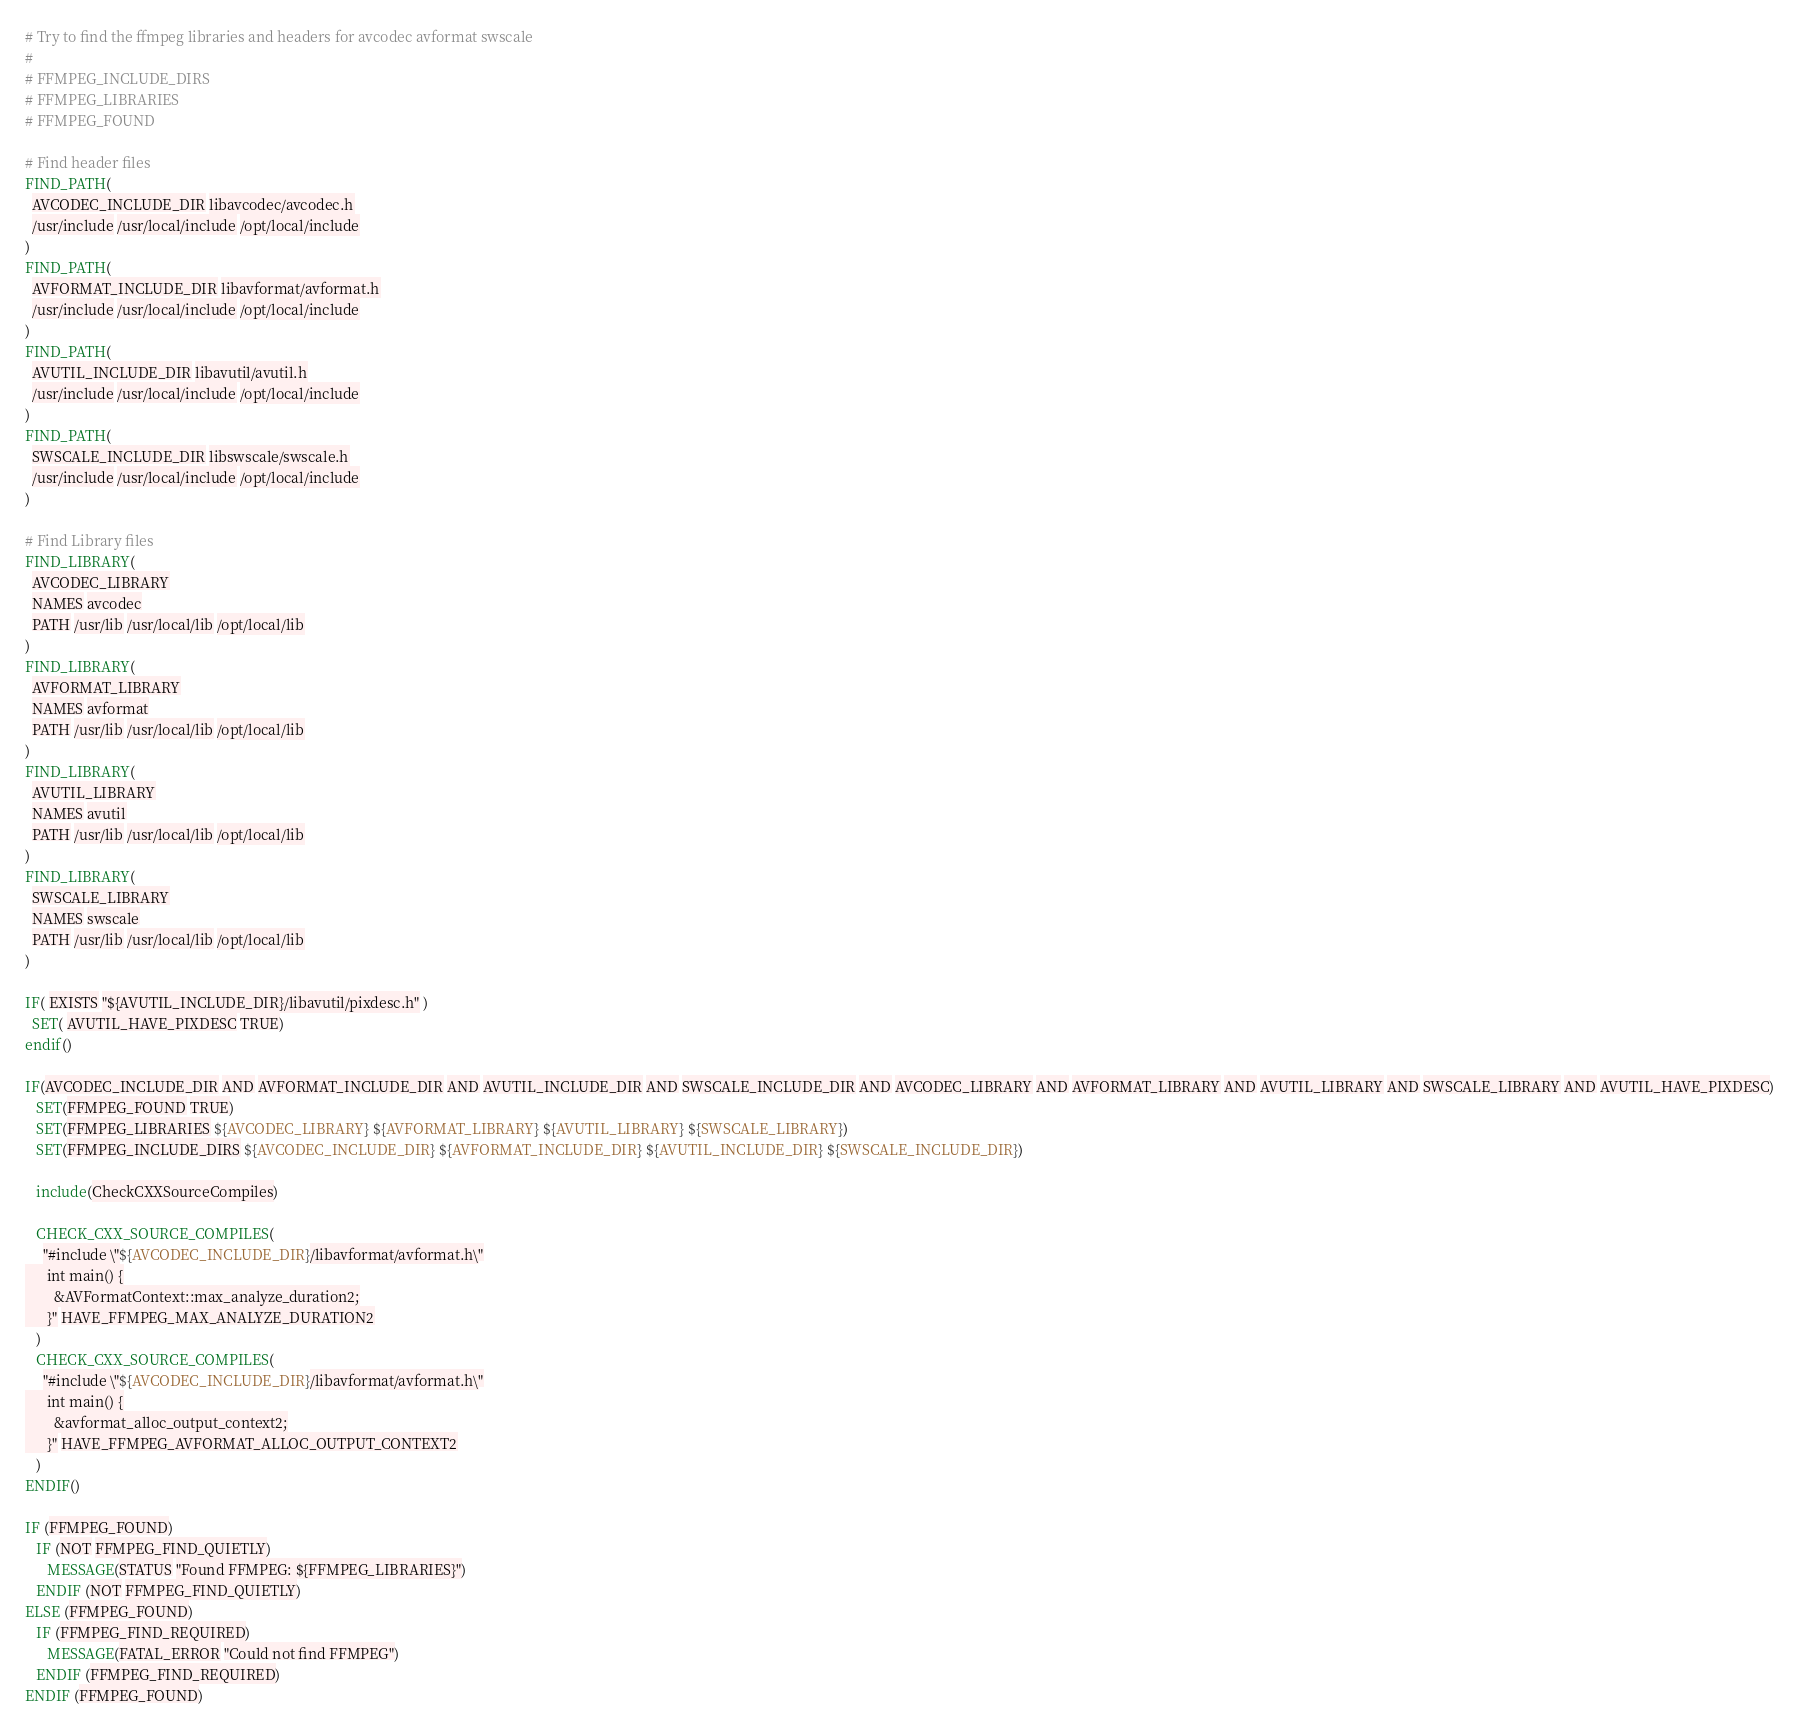<code> <loc_0><loc_0><loc_500><loc_500><_CMake_># Try to find the ffmpeg libraries and headers for avcodec avformat swscale
#
# FFMPEG_INCLUDE_DIRS
# FFMPEG_LIBRARIES
# FFMPEG_FOUND

# Find header files
FIND_PATH(
  AVCODEC_INCLUDE_DIR libavcodec/avcodec.h
  /usr/include /usr/local/include /opt/local/include
)
FIND_PATH(
  AVFORMAT_INCLUDE_DIR libavformat/avformat.h
  /usr/include /usr/local/include /opt/local/include
)
FIND_PATH(
  AVUTIL_INCLUDE_DIR libavutil/avutil.h
  /usr/include /usr/local/include /opt/local/include
)
FIND_PATH(
  SWSCALE_INCLUDE_DIR libswscale/swscale.h
  /usr/include /usr/local/include /opt/local/include
)

# Find Library files
FIND_LIBRARY(
  AVCODEC_LIBRARY
  NAMES avcodec
  PATH /usr/lib /usr/local/lib /opt/local/lib
)
FIND_LIBRARY(
  AVFORMAT_LIBRARY
  NAMES avformat
  PATH /usr/lib /usr/local/lib /opt/local/lib
)
FIND_LIBRARY(
  AVUTIL_LIBRARY
  NAMES avutil
  PATH /usr/lib /usr/local/lib /opt/local/lib
)
FIND_LIBRARY(
  SWSCALE_LIBRARY
  NAMES swscale
  PATH /usr/lib /usr/local/lib /opt/local/lib
)

IF( EXISTS "${AVUTIL_INCLUDE_DIR}/libavutil/pixdesc.h" )
  SET( AVUTIL_HAVE_PIXDESC TRUE)
endif()

IF(AVCODEC_INCLUDE_DIR AND AVFORMAT_INCLUDE_DIR AND AVUTIL_INCLUDE_DIR AND SWSCALE_INCLUDE_DIR AND AVCODEC_LIBRARY AND AVFORMAT_LIBRARY AND AVUTIL_LIBRARY AND SWSCALE_LIBRARY AND AVUTIL_HAVE_PIXDESC)
   SET(FFMPEG_FOUND TRUE)
   SET(FFMPEG_LIBRARIES ${AVCODEC_LIBRARY} ${AVFORMAT_LIBRARY} ${AVUTIL_LIBRARY} ${SWSCALE_LIBRARY})
   SET(FFMPEG_INCLUDE_DIRS ${AVCODEC_INCLUDE_DIR} ${AVFORMAT_INCLUDE_DIR} ${AVUTIL_INCLUDE_DIR} ${SWSCALE_INCLUDE_DIR})

   include(CheckCXXSourceCompiles)

   CHECK_CXX_SOURCE_COMPILES(
     "#include \"${AVCODEC_INCLUDE_DIR}/libavformat/avformat.h\"
      int main() {
        &AVFormatContext::max_analyze_duration2;
      }" HAVE_FFMPEG_MAX_ANALYZE_DURATION2
   )
   CHECK_CXX_SOURCE_COMPILES(
     "#include \"${AVCODEC_INCLUDE_DIR}/libavformat/avformat.h\"
      int main() {
        &avformat_alloc_output_context2;
      }" HAVE_FFMPEG_AVFORMAT_ALLOC_OUTPUT_CONTEXT2
   )
ENDIF()

IF (FFMPEG_FOUND)
   IF (NOT FFMPEG_FIND_QUIETLY)
      MESSAGE(STATUS "Found FFMPEG: ${FFMPEG_LIBRARIES}")
   ENDIF (NOT FFMPEG_FIND_QUIETLY)
ELSE (FFMPEG_FOUND)
   IF (FFMPEG_FIND_REQUIRED)
      MESSAGE(FATAL_ERROR "Could not find FFMPEG")
   ENDIF (FFMPEG_FIND_REQUIRED)
ENDIF (FFMPEG_FOUND)
</code> 